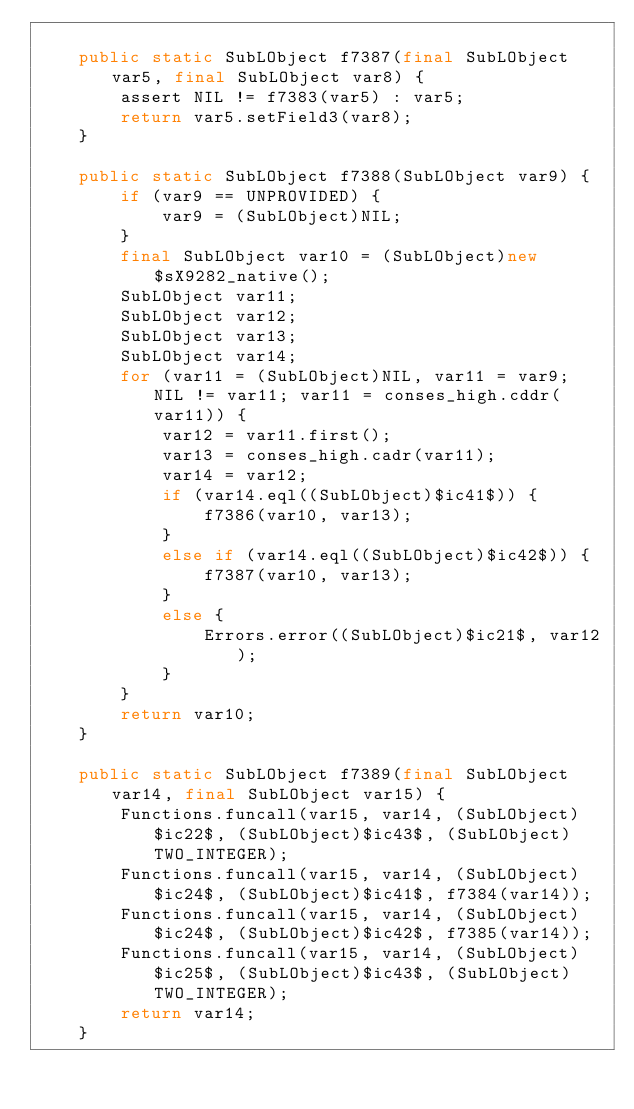Convert code to text. <code><loc_0><loc_0><loc_500><loc_500><_Java_>    
    public static SubLObject f7387(final SubLObject var5, final SubLObject var8) {
        assert NIL != f7383(var5) : var5;
        return var5.setField3(var8);
    }
    
    public static SubLObject f7388(SubLObject var9) {
        if (var9 == UNPROVIDED) {
            var9 = (SubLObject)NIL;
        }
        final SubLObject var10 = (SubLObject)new $sX9282_native();
        SubLObject var11;
        SubLObject var12;
        SubLObject var13;
        SubLObject var14;
        for (var11 = (SubLObject)NIL, var11 = var9; NIL != var11; var11 = conses_high.cddr(var11)) {
            var12 = var11.first();
            var13 = conses_high.cadr(var11);
            var14 = var12;
            if (var14.eql((SubLObject)$ic41$)) {
                f7386(var10, var13);
            }
            else if (var14.eql((SubLObject)$ic42$)) {
                f7387(var10, var13);
            }
            else {
                Errors.error((SubLObject)$ic21$, var12);
            }
        }
        return var10;
    }
    
    public static SubLObject f7389(final SubLObject var14, final SubLObject var15) {
        Functions.funcall(var15, var14, (SubLObject)$ic22$, (SubLObject)$ic43$, (SubLObject)TWO_INTEGER);
        Functions.funcall(var15, var14, (SubLObject)$ic24$, (SubLObject)$ic41$, f7384(var14));
        Functions.funcall(var15, var14, (SubLObject)$ic24$, (SubLObject)$ic42$, f7385(var14));
        Functions.funcall(var15, var14, (SubLObject)$ic25$, (SubLObject)$ic43$, (SubLObject)TWO_INTEGER);
        return var14;
    }
    </code> 